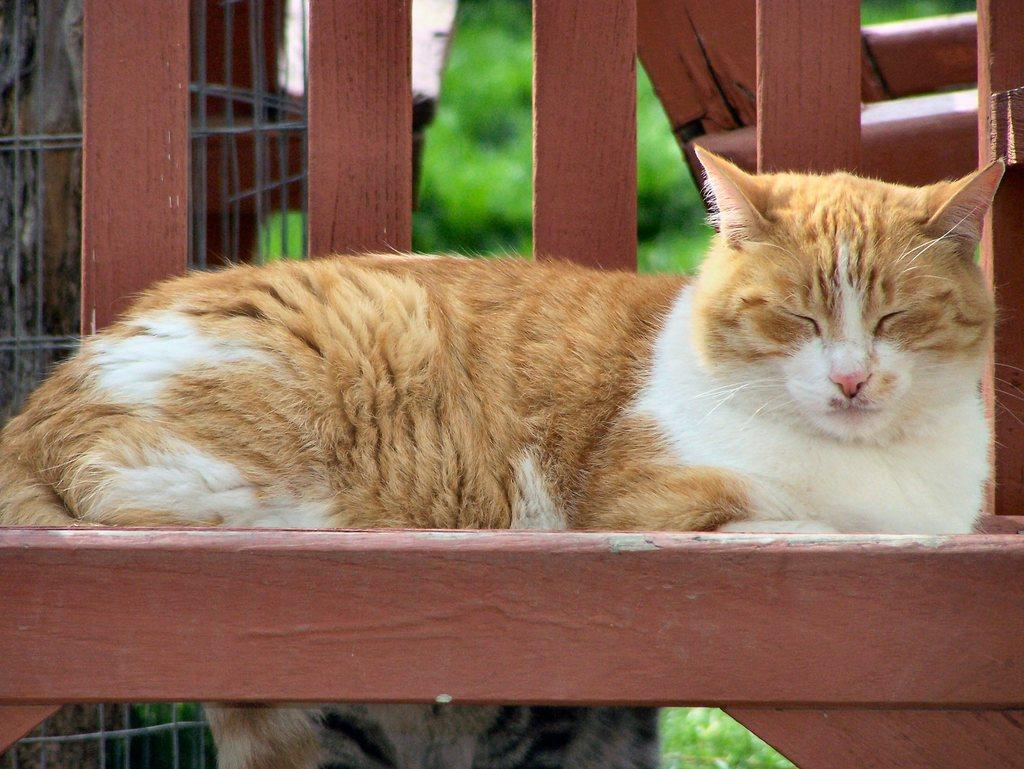What animal is present on a wooden surface in the image? There is a cat on a wooden surface in the image. Where is the wooden surface located in relation to the image? The wooden surface is in the foreground area of the image. What can be seen in the background of the image? There appears to be a tree and a mesh in the background of the image. What type of material is visible in the background of the image? Wooden planks are visible in the background of the image. What effect does the cat's cough have on the wooden planks in the image? There is no mention of the cat coughing in the image, and therefore no effect on the wooden planks can be determined. 